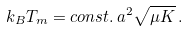<formula> <loc_0><loc_0><loc_500><loc_500>k _ { B } T _ { m } = { c o n s t . } \, a ^ { 2 } \sqrt { \mu K } \, .</formula> 